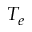Convert formula to latex. <formula><loc_0><loc_0><loc_500><loc_500>T _ { e }</formula> 